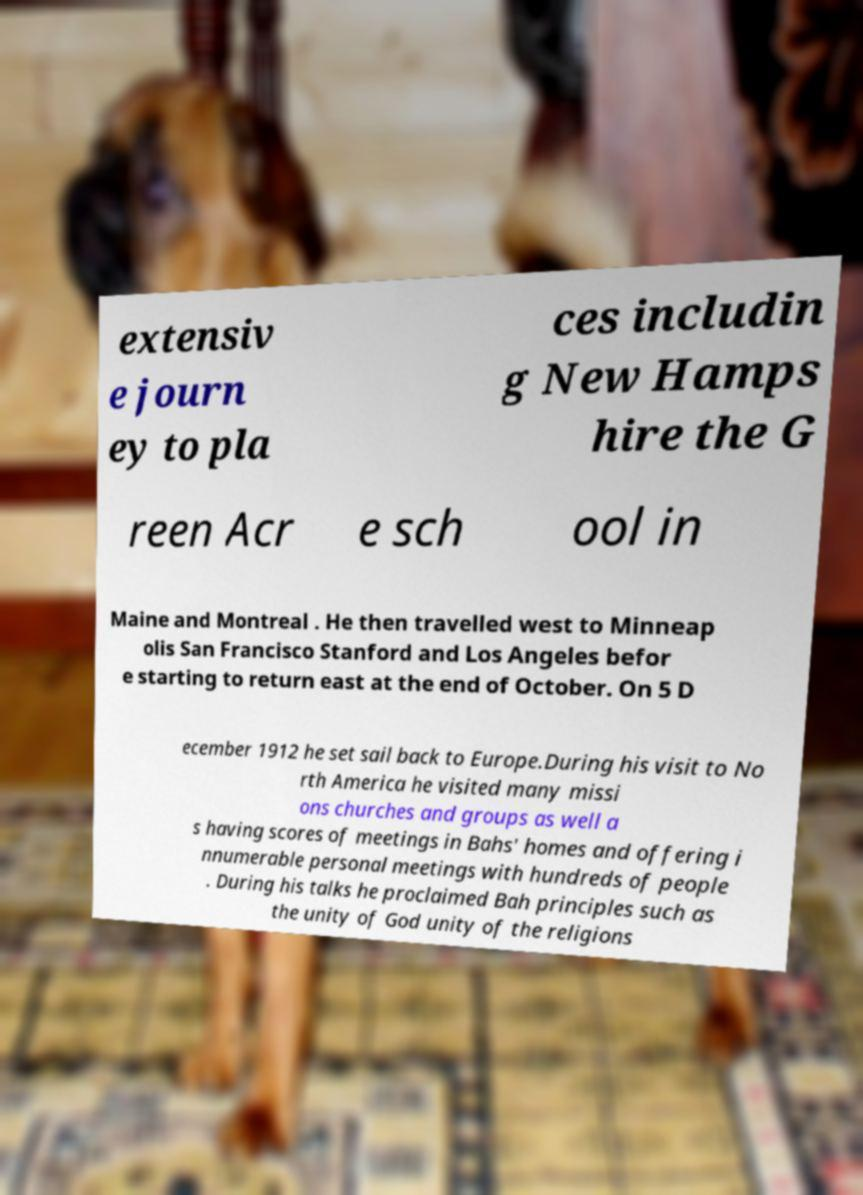Could you assist in decoding the text presented in this image and type it out clearly? extensiv e journ ey to pla ces includin g New Hamps hire the G reen Acr e sch ool in Maine and Montreal . He then travelled west to Minneap olis San Francisco Stanford and Los Angeles befor e starting to return east at the end of October. On 5 D ecember 1912 he set sail back to Europe.During his visit to No rth America he visited many missi ons churches and groups as well a s having scores of meetings in Bahs' homes and offering i nnumerable personal meetings with hundreds of people . During his talks he proclaimed Bah principles such as the unity of God unity of the religions 